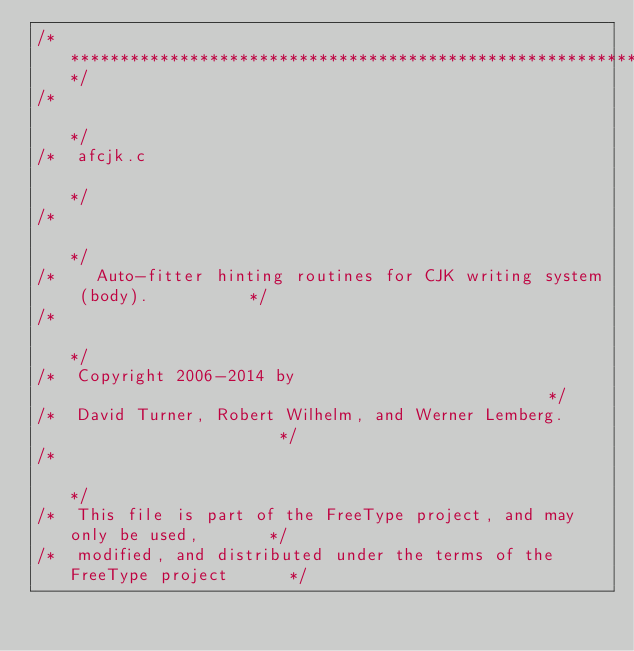<code> <loc_0><loc_0><loc_500><loc_500><_C_>/***************************************************************************/
/*                                                                         */
/*  afcjk.c                                                                */
/*                                                                         */
/*    Auto-fitter hinting routines for CJK writing system (body).          */
/*                                                                         */
/*  Copyright 2006-2014 by                                                 */
/*  David Turner, Robert Wilhelm, and Werner Lemberg.                      */
/*                                                                         */
/*  This file is part of the FreeType project, and may only be used,       */
/*  modified, and distributed under the terms of the FreeType project      */</code> 